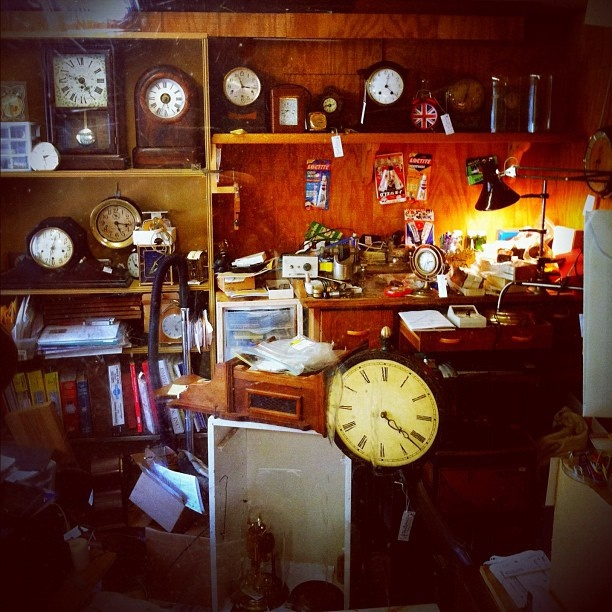Describe the objects in this image and their specific colors. I can see clock in black, maroon, and gray tones, clock in black, khaki, and olive tones, clock in black, darkgray, gray, and lightgray tones, clock in black, lightgray, darkgray, and maroon tones, and book in black, maroon, purple, and lavender tones in this image. 